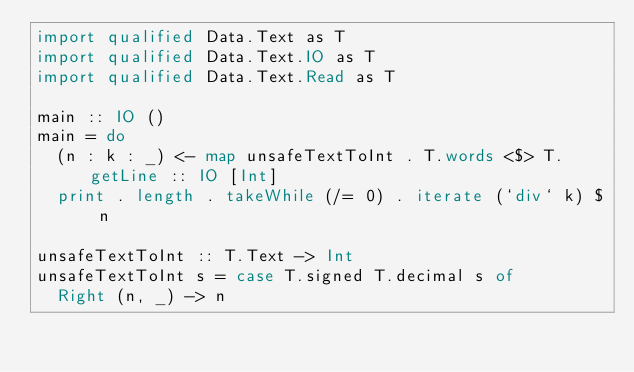<code> <loc_0><loc_0><loc_500><loc_500><_Haskell_>import qualified Data.Text as T
import qualified Data.Text.IO as T
import qualified Data.Text.Read as T

main :: IO ()
main = do
  (n : k : _) <- map unsafeTextToInt . T.words <$> T.getLine :: IO [Int]
  print . length . takeWhile (/= 0) . iterate (`div` k) $ n

unsafeTextToInt :: T.Text -> Int
unsafeTextToInt s = case T.signed T.decimal s of
  Right (n, _) -> n
</code> 